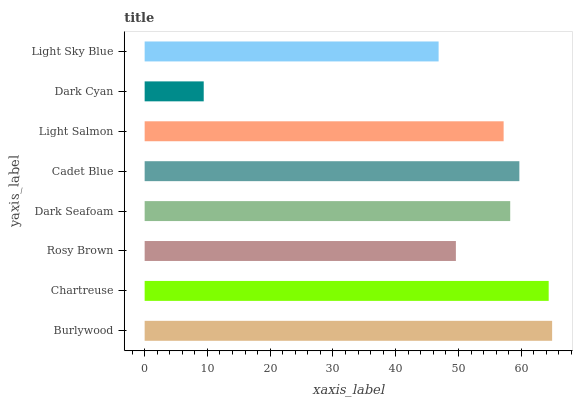Is Dark Cyan the minimum?
Answer yes or no. Yes. Is Burlywood the maximum?
Answer yes or no. Yes. Is Chartreuse the minimum?
Answer yes or no. No. Is Chartreuse the maximum?
Answer yes or no. No. Is Burlywood greater than Chartreuse?
Answer yes or no. Yes. Is Chartreuse less than Burlywood?
Answer yes or no. Yes. Is Chartreuse greater than Burlywood?
Answer yes or no. No. Is Burlywood less than Chartreuse?
Answer yes or no. No. Is Dark Seafoam the high median?
Answer yes or no. Yes. Is Light Salmon the low median?
Answer yes or no. Yes. Is Burlywood the high median?
Answer yes or no. No. Is Burlywood the low median?
Answer yes or no. No. 